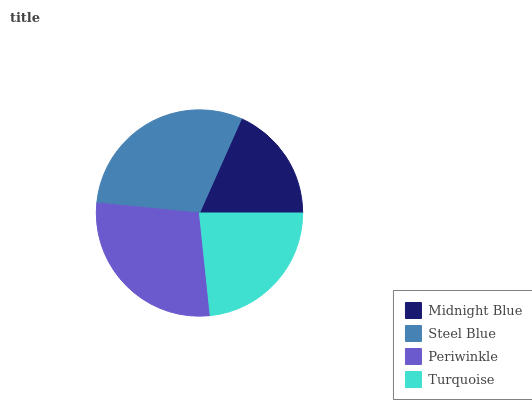Is Midnight Blue the minimum?
Answer yes or no. Yes. Is Steel Blue the maximum?
Answer yes or no. Yes. Is Periwinkle the minimum?
Answer yes or no. No. Is Periwinkle the maximum?
Answer yes or no. No. Is Steel Blue greater than Periwinkle?
Answer yes or no. Yes. Is Periwinkle less than Steel Blue?
Answer yes or no. Yes. Is Periwinkle greater than Steel Blue?
Answer yes or no. No. Is Steel Blue less than Periwinkle?
Answer yes or no. No. Is Periwinkle the high median?
Answer yes or no. Yes. Is Turquoise the low median?
Answer yes or no. Yes. Is Midnight Blue the high median?
Answer yes or no. No. Is Steel Blue the low median?
Answer yes or no. No. 